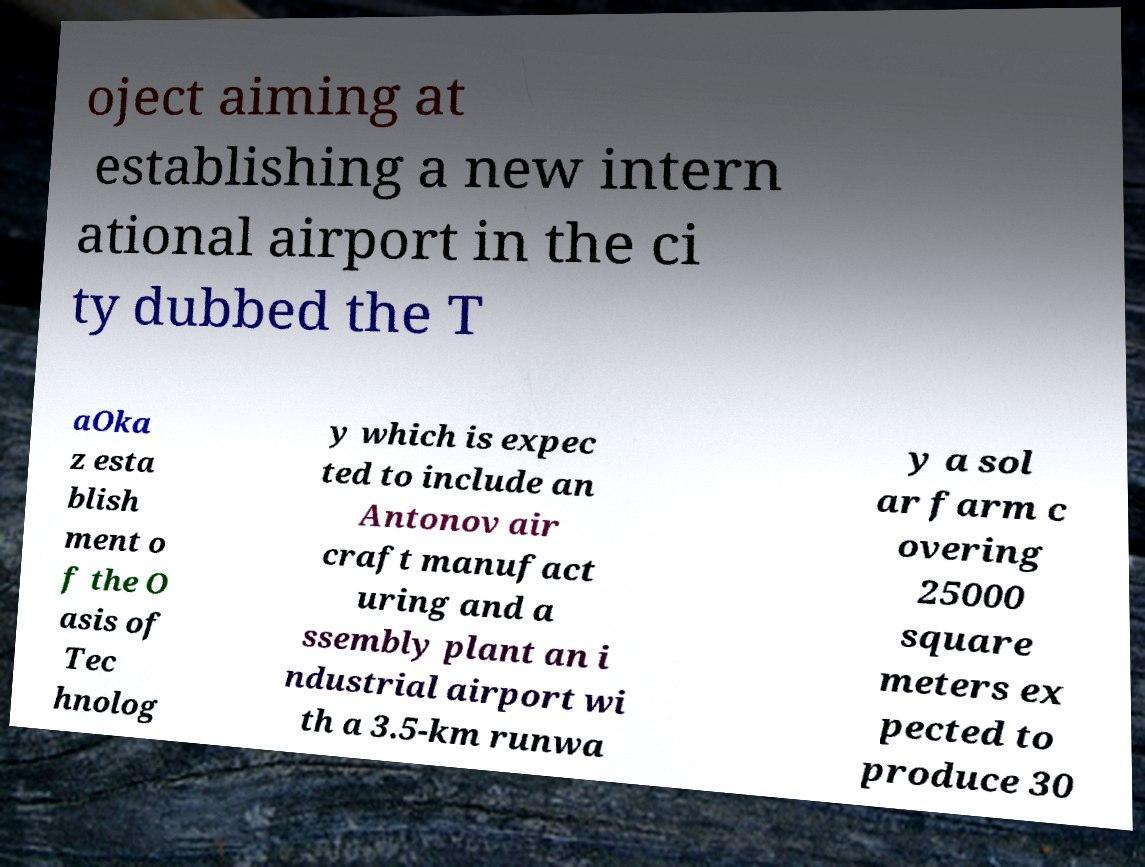There's text embedded in this image that I need extracted. Can you transcribe it verbatim? oject aiming at establishing a new intern ational airport in the ci ty dubbed the T aOka z esta blish ment o f the O asis of Tec hnolog y which is expec ted to include an Antonov air craft manufact uring and a ssembly plant an i ndustrial airport wi th a 3.5-km runwa y a sol ar farm c overing 25000 square meters ex pected to produce 30 